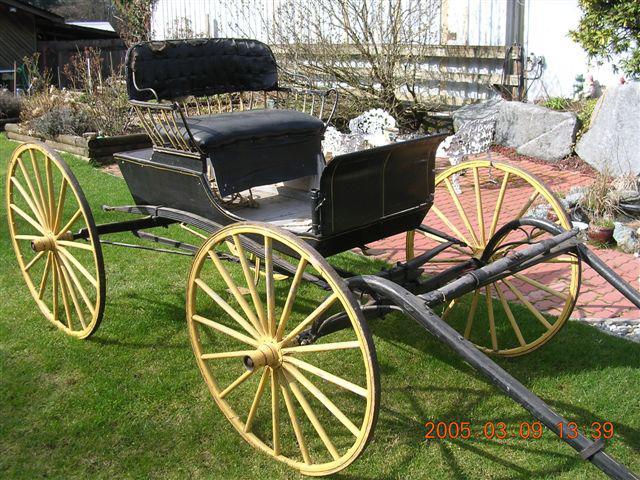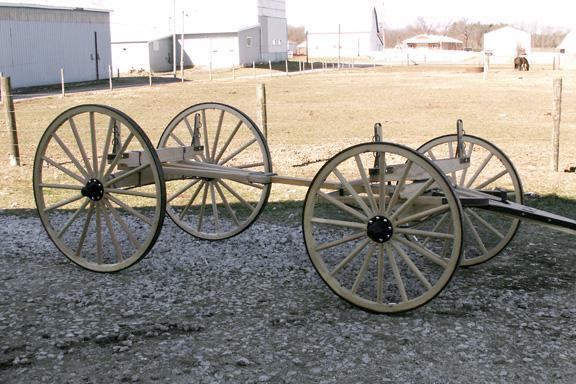The first image is the image on the left, the second image is the image on the right. Assess this claim about the two images: "At least one of the carts is rectagular and made of wood.". Correct or not? Answer yes or no. No. The first image is the image on the left, the second image is the image on the right. Considering the images on both sides, is "An image shows a wooden two-wheeled cart with 'handles' tilted to the ground." valid? Answer yes or no. No. 